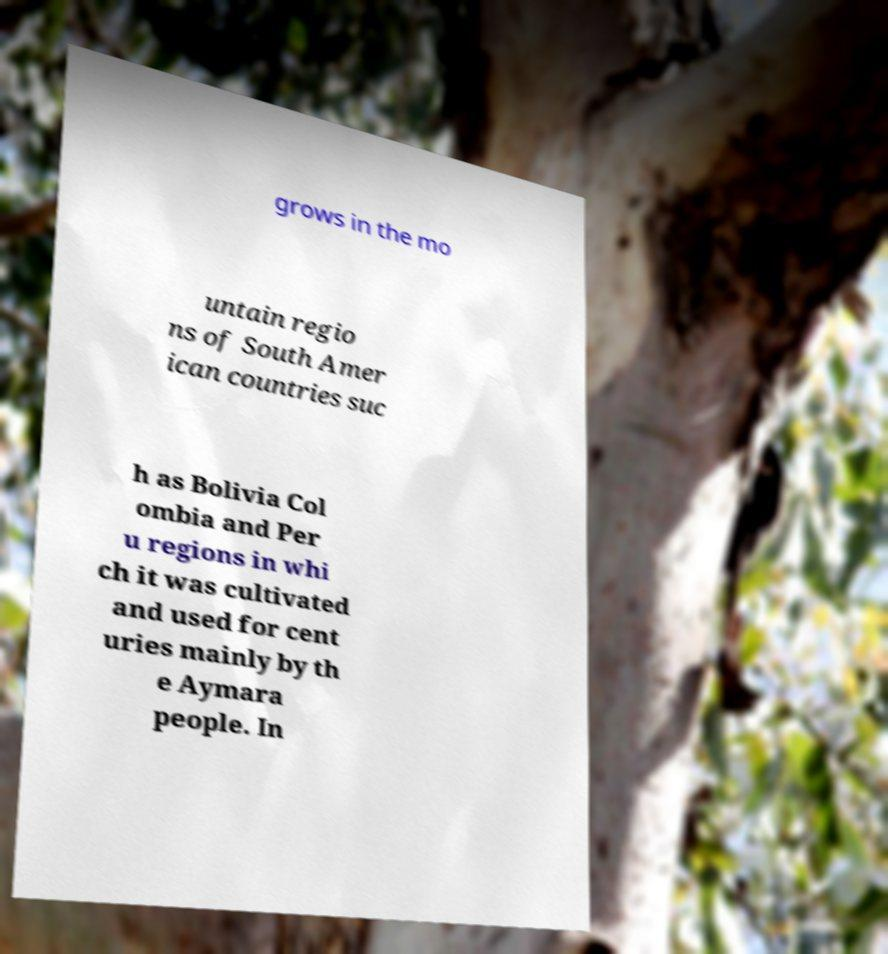Could you extract and type out the text from this image? grows in the mo untain regio ns of South Amer ican countries suc h as Bolivia Col ombia and Per u regions in whi ch it was cultivated and used for cent uries mainly by th e Aymara people. In 